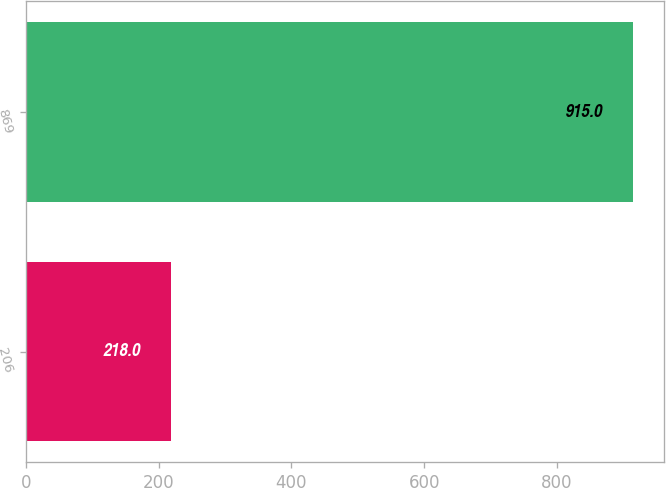<chart> <loc_0><loc_0><loc_500><loc_500><bar_chart><fcel>206<fcel>869<nl><fcel>218<fcel>915<nl></chart> 